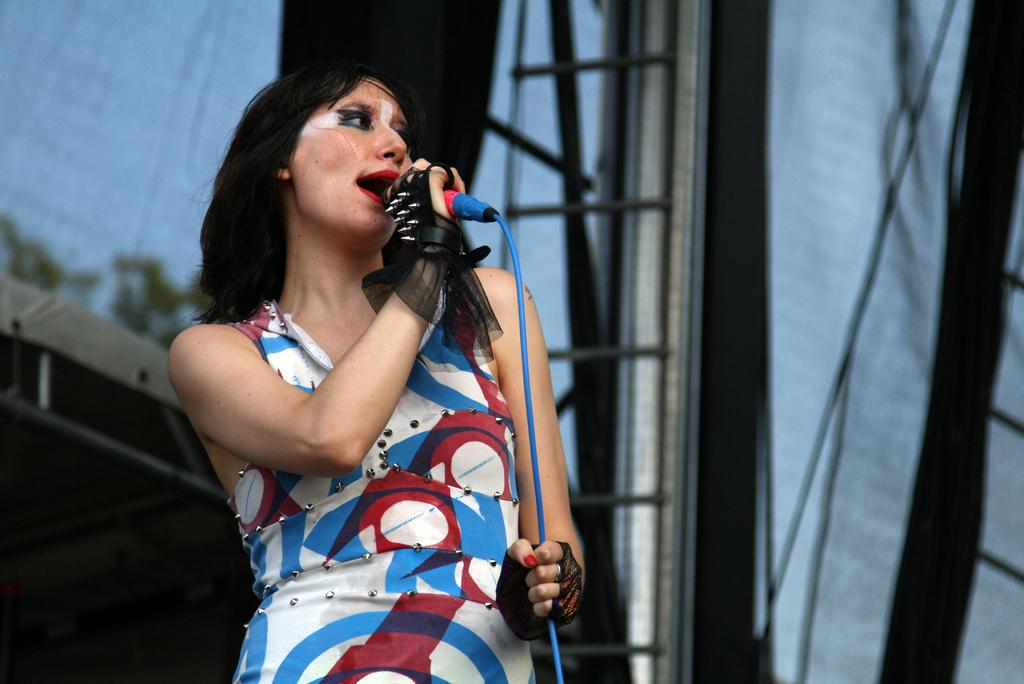Who is the main subject in the image? There is a woman in the image. What is the woman holding in the image? The woman is holding a microphone. What is the woman doing with the microphone? The woman is singing a song. What can be seen behind the woman in the image? The background of the image is a cloth. What type of hat is the woman wearing in the image? There is no hat present in the image; the woman is not wearing a hat. Can you provide an example of a song the woman might be singing in the image? It is not possible to determine the specific song the woman is singing in the image based on the provided facts. 